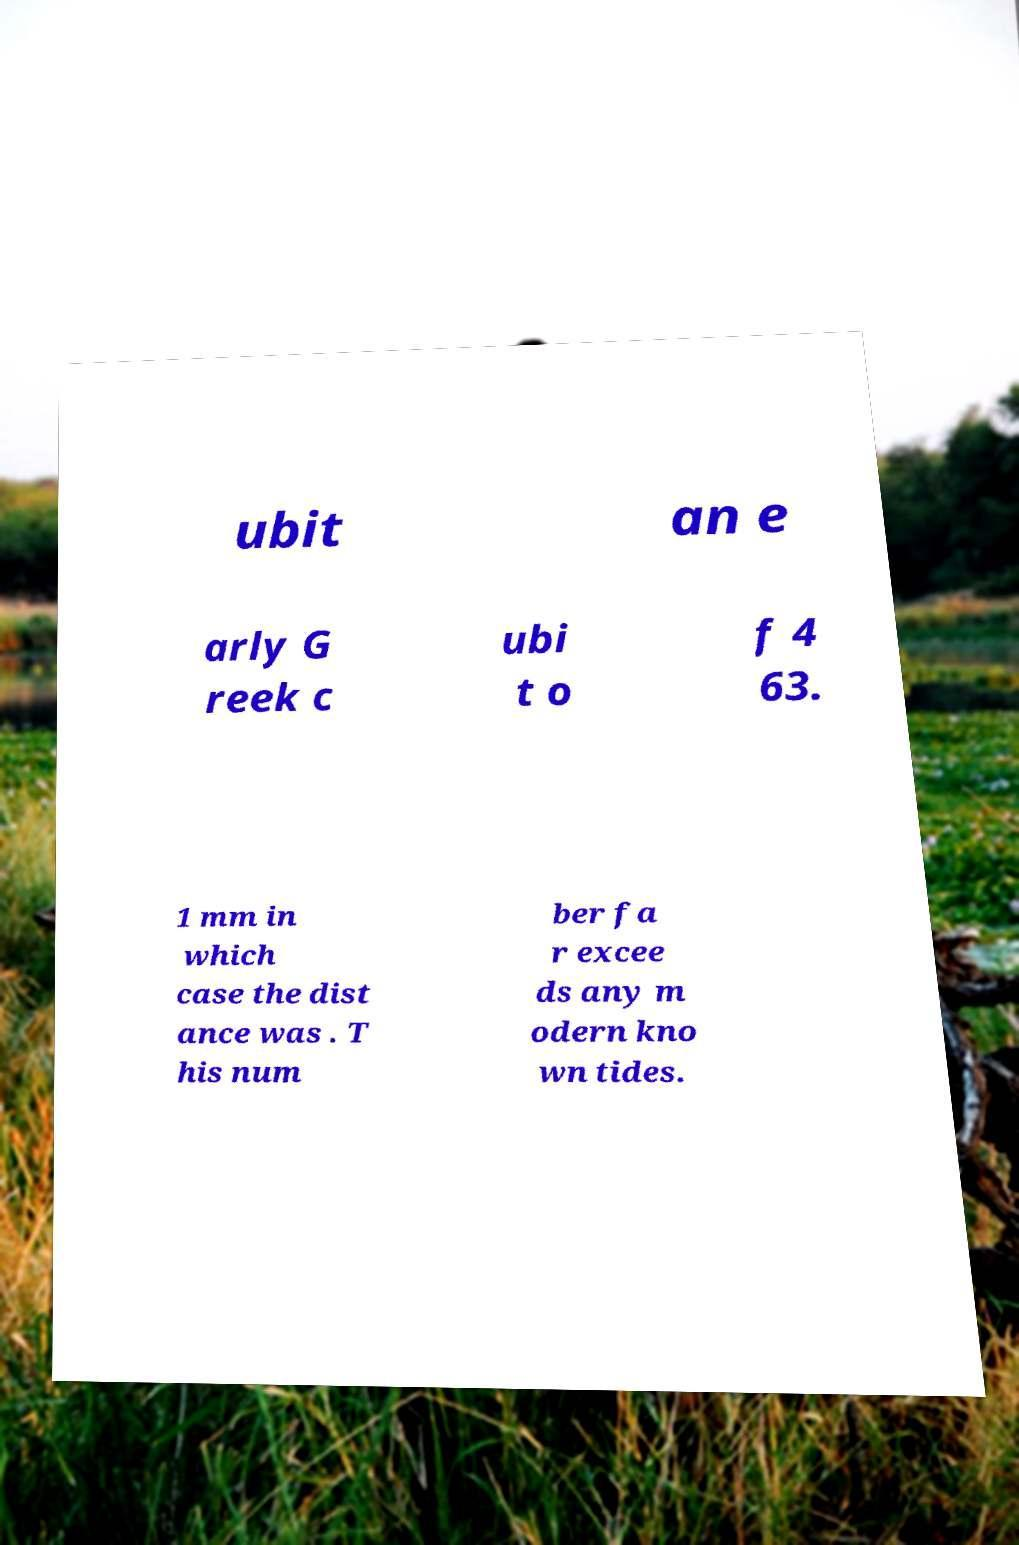What messages or text are displayed in this image? I need them in a readable, typed format. ubit an e arly G reek c ubi t o f 4 63. 1 mm in which case the dist ance was . T his num ber fa r excee ds any m odern kno wn tides. 